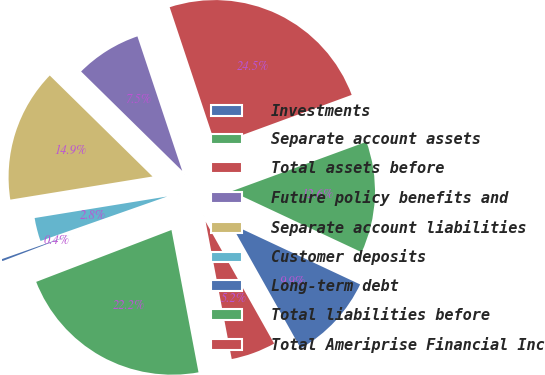Convert chart. <chart><loc_0><loc_0><loc_500><loc_500><pie_chart><fcel>Investments<fcel>Separate account assets<fcel>Total assets before<fcel>Future policy benefits and<fcel>Separate account liabilities<fcel>Customer deposits<fcel>Long-term debt<fcel>Total liabilities before<fcel>Total Ameriprise Financial Inc<nl><fcel>9.88%<fcel>12.57%<fcel>24.52%<fcel>7.52%<fcel>14.93%<fcel>2.81%<fcel>0.45%<fcel>22.16%<fcel>5.16%<nl></chart> 